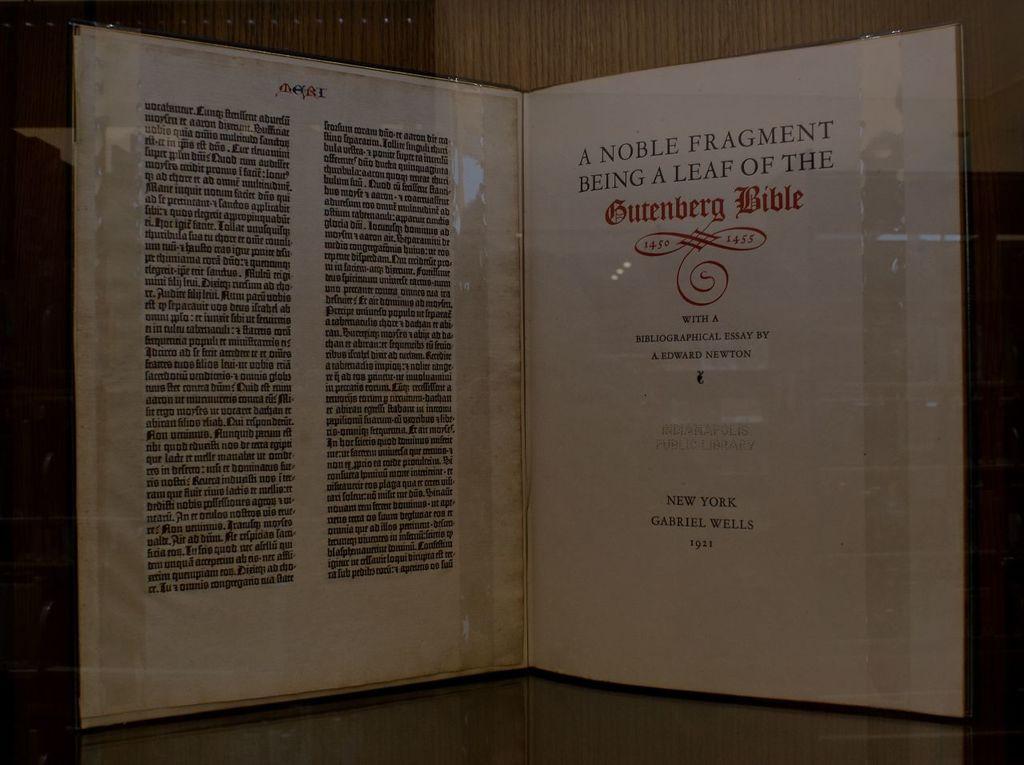Who wrote the bibliographical essay for this novel?
Ensure brevity in your answer.  A. edward newton. What year was this published?
Make the answer very short. 1921. 